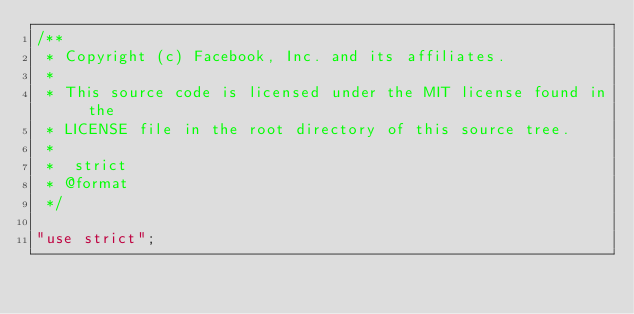<code> <loc_0><loc_0><loc_500><loc_500><_JavaScript_>/**
 * Copyright (c) Facebook, Inc. and its affiliates.
 *
 * This source code is licensed under the MIT license found in the
 * LICENSE file in the root directory of this source tree.
 *
 *  strict
 * @format
 */

"use strict";</code> 